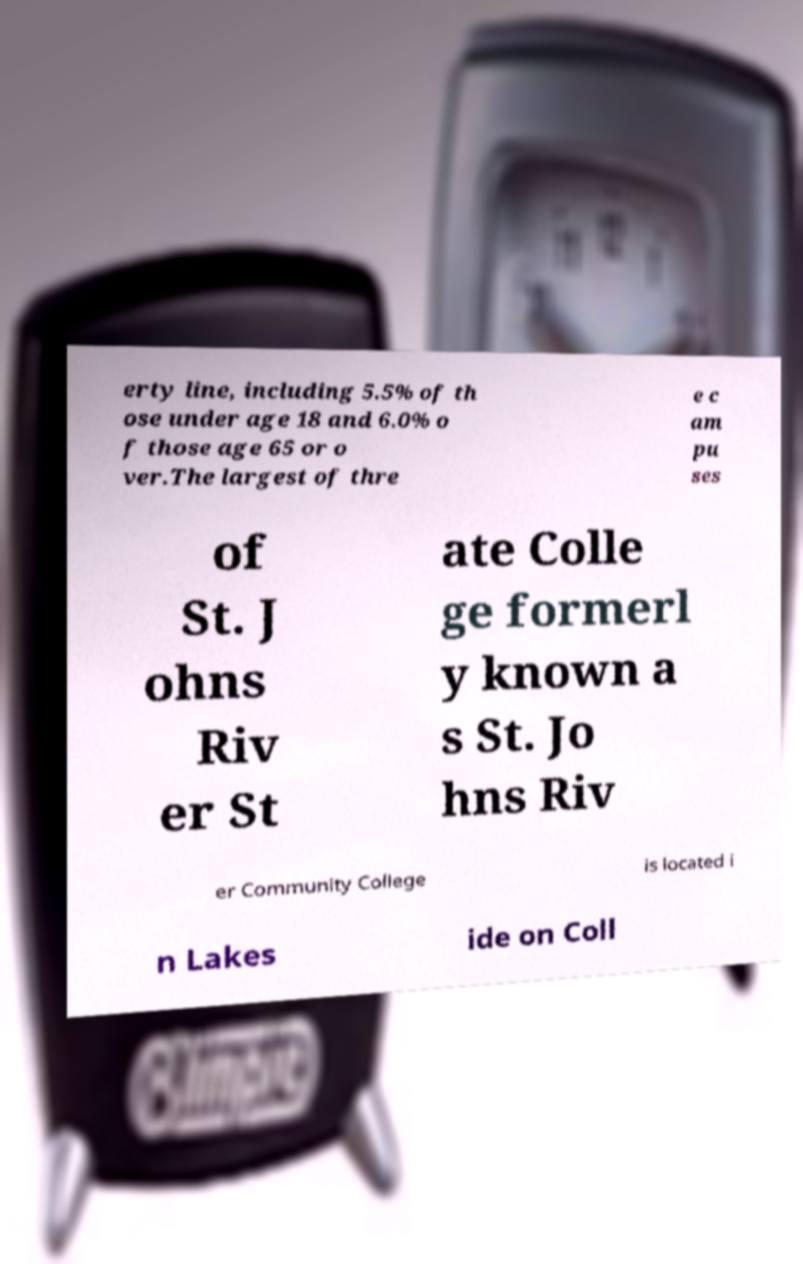I need the written content from this picture converted into text. Can you do that? erty line, including 5.5% of th ose under age 18 and 6.0% o f those age 65 or o ver.The largest of thre e c am pu ses of St. J ohns Riv er St ate Colle ge formerl y known a s St. Jo hns Riv er Community College is located i n Lakes ide on Coll 